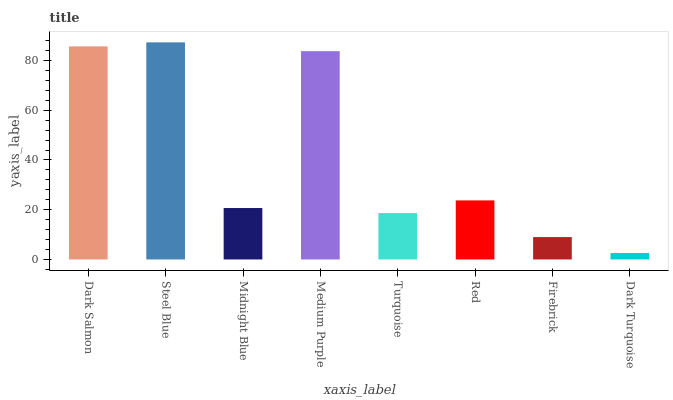Is Dark Turquoise the minimum?
Answer yes or no. Yes. Is Steel Blue the maximum?
Answer yes or no. Yes. Is Midnight Blue the minimum?
Answer yes or no. No. Is Midnight Blue the maximum?
Answer yes or no. No. Is Steel Blue greater than Midnight Blue?
Answer yes or no. Yes. Is Midnight Blue less than Steel Blue?
Answer yes or no. Yes. Is Midnight Blue greater than Steel Blue?
Answer yes or no. No. Is Steel Blue less than Midnight Blue?
Answer yes or no. No. Is Red the high median?
Answer yes or no. Yes. Is Midnight Blue the low median?
Answer yes or no. Yes. Is Steel Blue the high median?
Answer yes or no. No. Is Turquoise the low median?
Answer yes or no. No. 